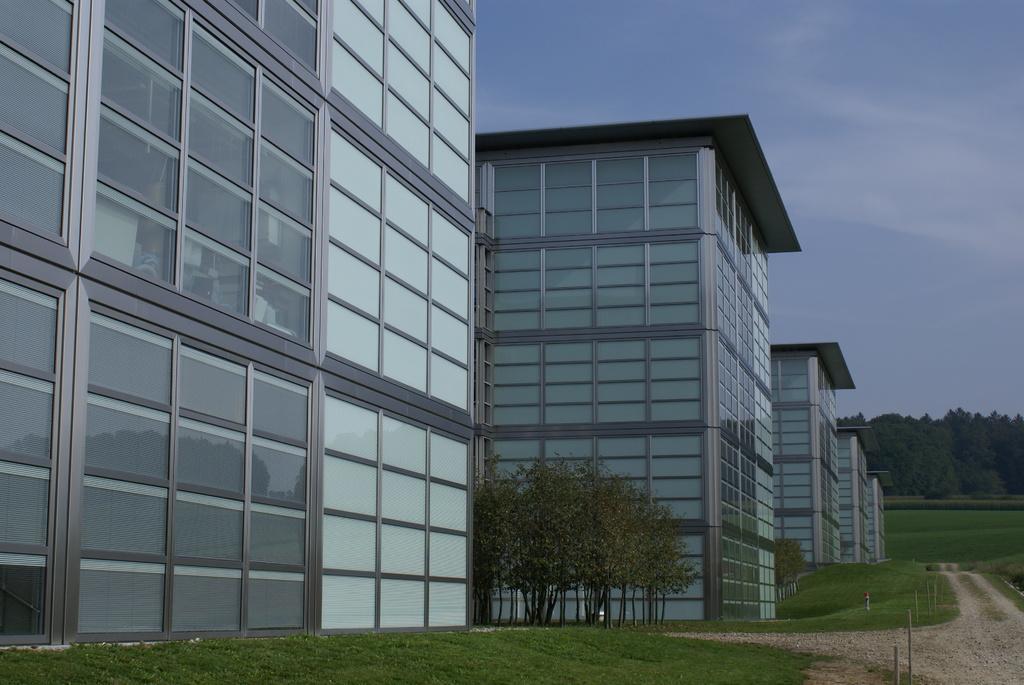Could you give a brief overview of what you see in this image? In this picture I can see many buildings. At the bottom I can see the grass and poles. In the background I can see many trees and plants. At the top there is a sky and clouds. Inside the building I can see table, wall partition and other objects. 